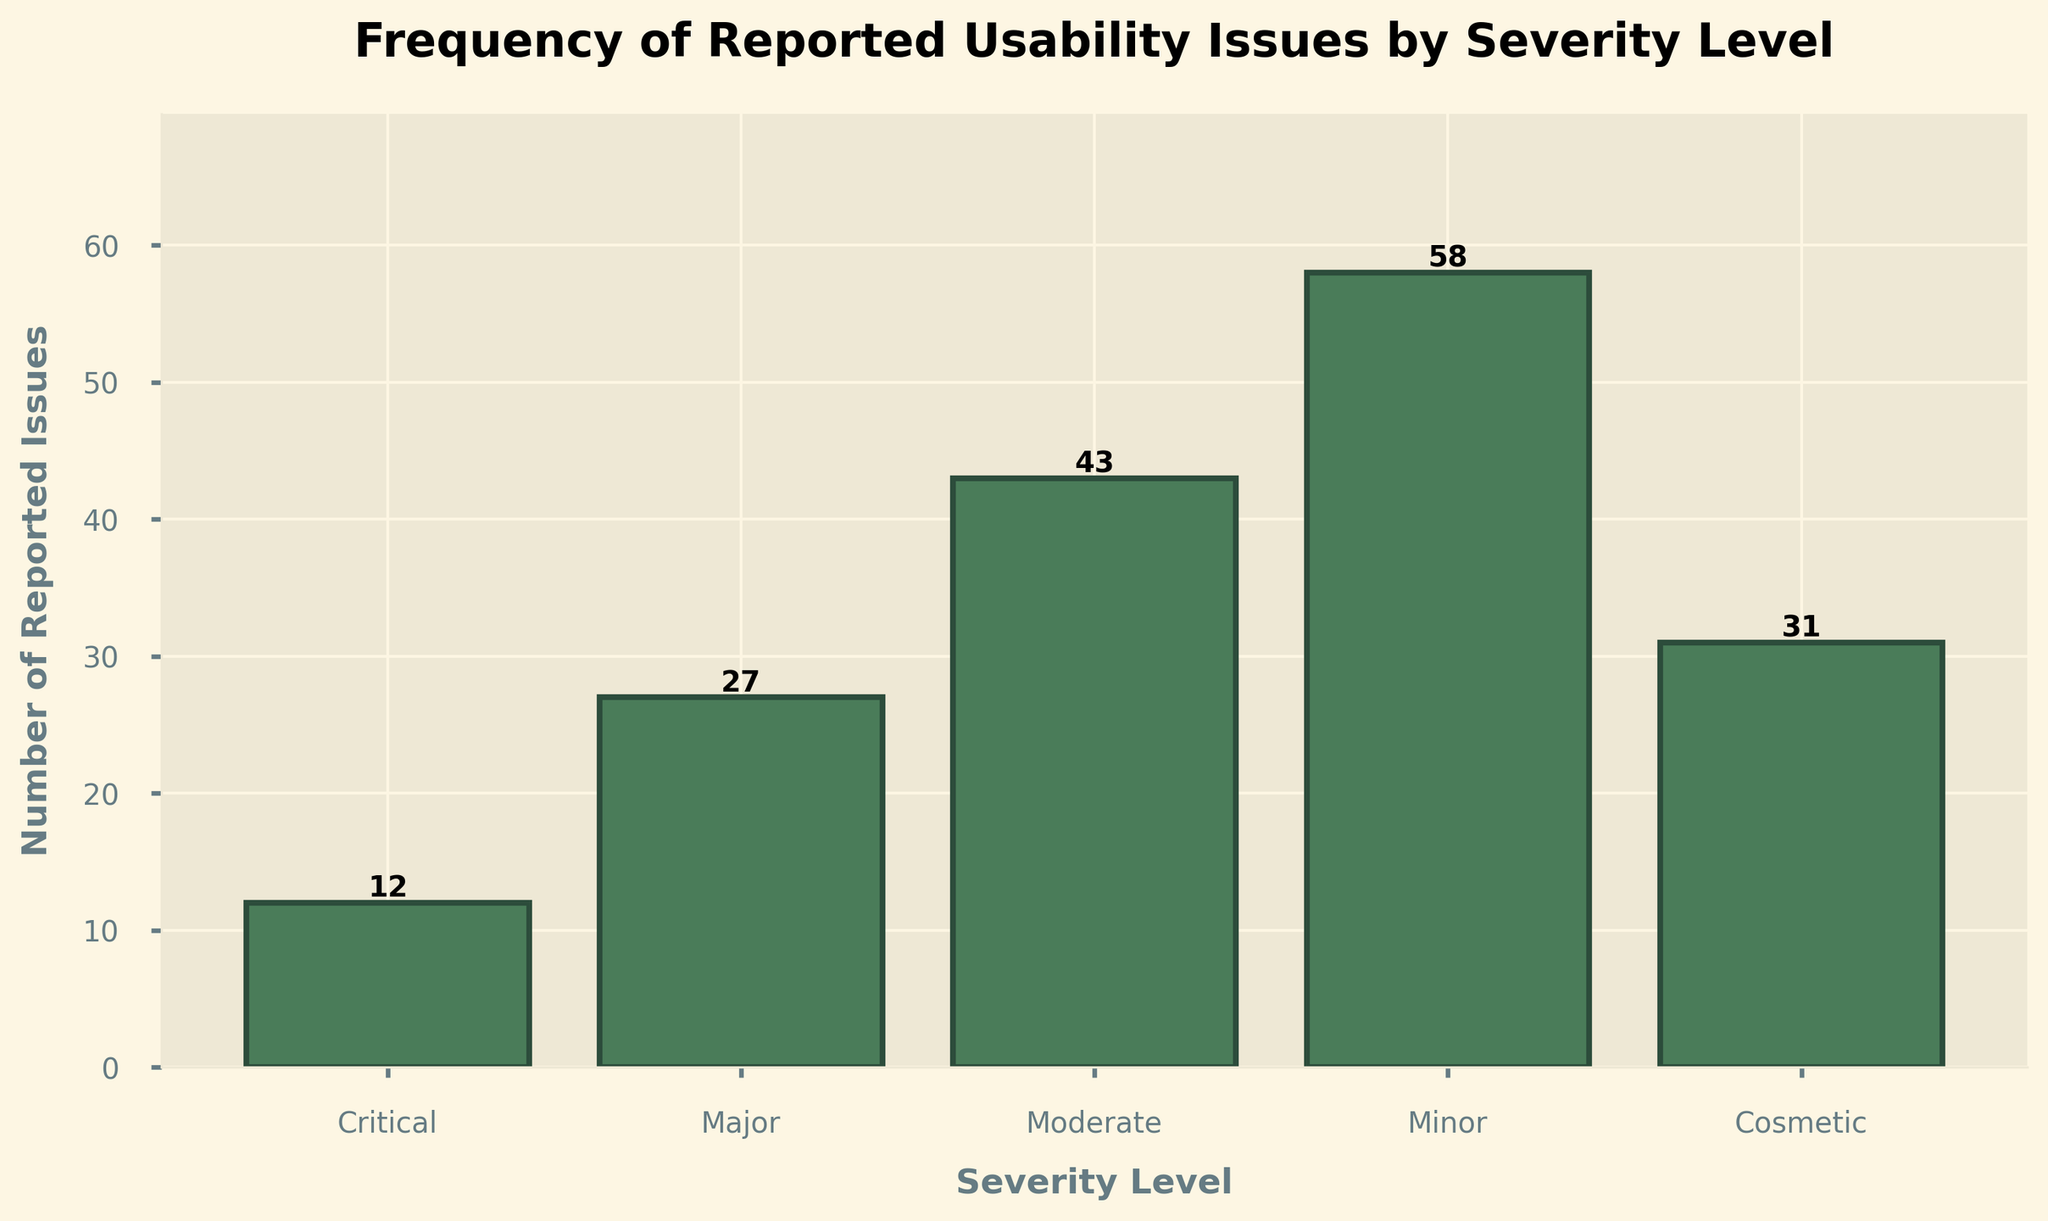Which severity level has the most reported usability issues? The height of the bar for 'Minor' severity level is the tallest among all the bars, indicating that it has the highest number of reported usability issues.
Answer: Minor What is the total number of reported issues across all severity levels? Add the heights of all the bars: 12 (Critical) + 27 (Major) + 43 (Moderate) + 58 (Minor) + 31 (Cosmetic) = 171.
Answer: 171 What is the difference in the number of reported issues between the 'Major' and 'Moderate' severity levels? Subtract the number of reported issues for Major (27) from the number for Moderate (43): 43 - 27 = 16.
Answer: 16 Which severity level has the fewest reported usability issues? The bar for the 'Critical' severity level is the shortest, indicating it has the fewest reported issues.
Answer: Critical How many more usability issues were reported for 'Minor' severity compared to 'Cosmetic' severity? Subtract the number of reported issues for Cosmetic (31) from the number for Minor (58): 58 - 31 = 27.
Answer: 27 What is the average number of reported usability issues across all severity levels? Calculate the total number of reported issues (171) and divide by the number of severity levels (5): 171 / 5 = 34.2.
Answer: 34.2 If you combine the number of reported issues for 'Critical' and 'Cosmetic' severity levels, does it exceed the number of issues reported for 'Moderate' severity? Add the number of reported issues for Critical (12) and Cosmetic (31): 12 + 31 = 43. Since 43 is equal to the number of issues for Moderate (43), it does not exceed.
Answer: No, it equals 43 What is the ratio of reported usability issues between 'Minor' and 'Critical' severity levels? Divide the number of reported issues for Minor (58) by the number of reported issues for Critical (12): 58 / 12 ≈ 4.83.
Answer: 4.83 If the number of reported 'Minor' usability issues were reduced by 20, how many total issues would there be then? Subtract 20 from the number of Minor issues (58): 58 - 20 = 38. Add this to the total from other levels: 12 (Critical) + 27 (Major) + 43 (Moderate) + 38 (revised Minor) + 31 (Cosmetic) = 151.
Answer: 151 